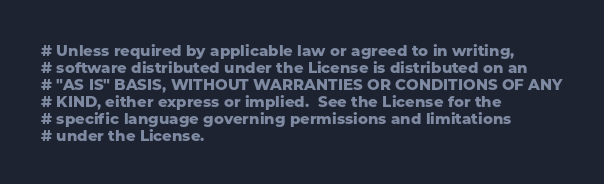Convert code to text. <code><loc_0><loc_0><loc_500><loc_500><_Python_># Unless required by applicable law or agreed to in writing,
# software distributed under the License is distributed on an
# "AS IS" BASIS, WITHOUT WARRANTIES OR CONDITIONS OF ANY
# KIND, either express or implied.  See the License for the
# specific language governing permissions and limitations
# under the License.</code> 